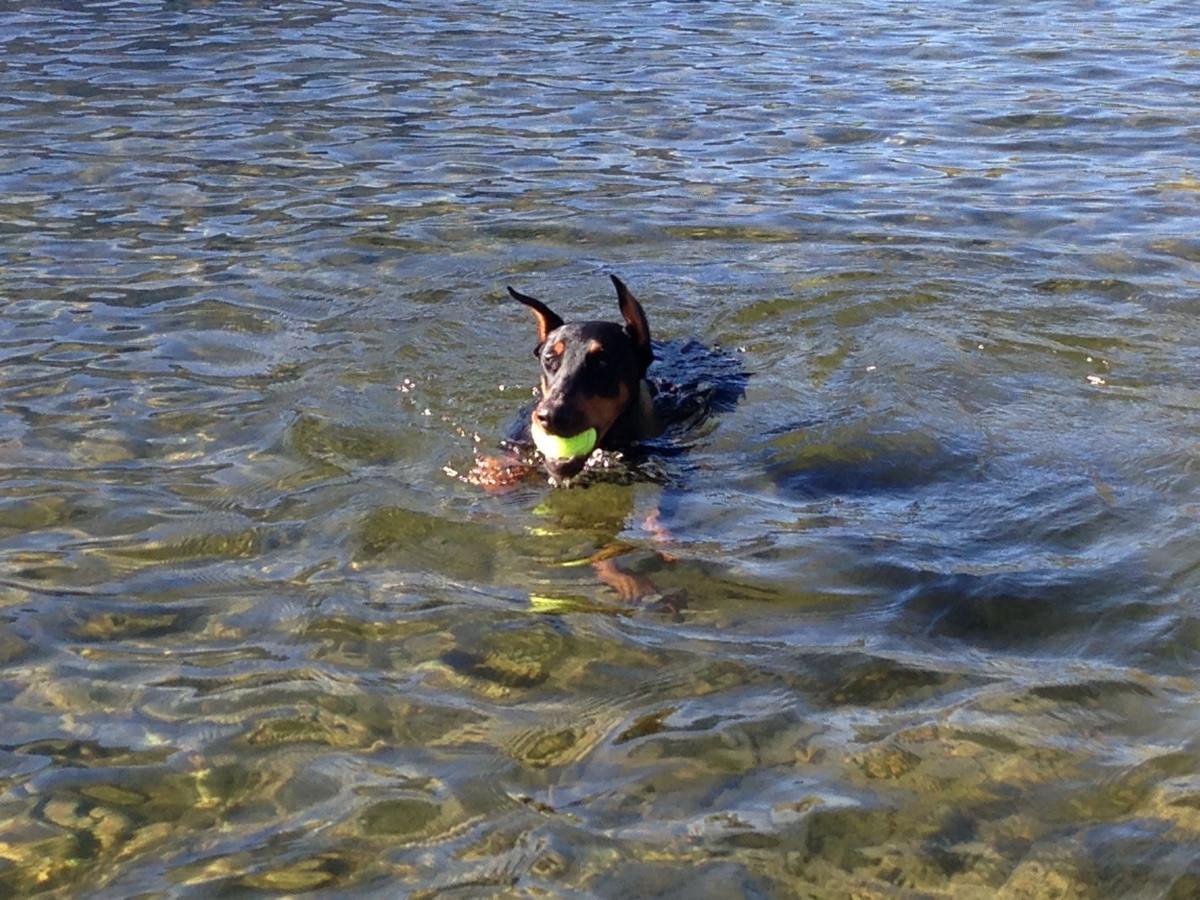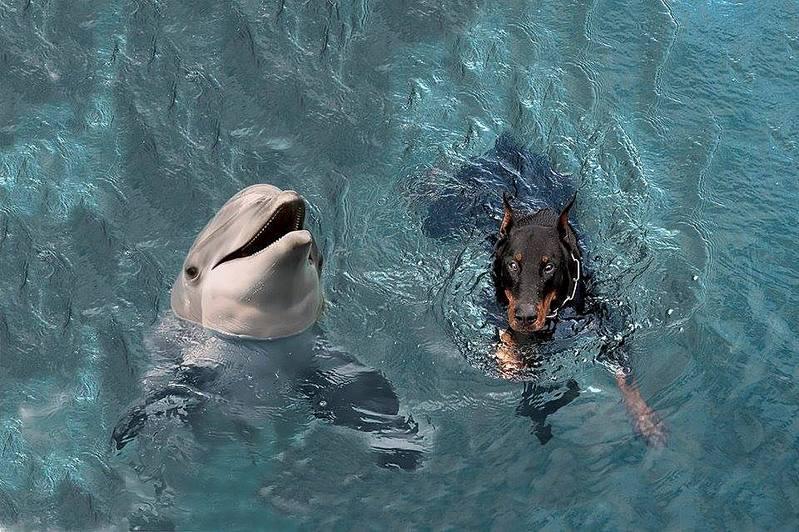The first image is the image on the left, the second image is the image on the right. Evaluate the accuracy of this statement regarding the images: "The dog in each image is alone in the water.". Is it true? Answer yes or no. No. The first image is the image on the left, the second image is the image on the right. Evaluate the accuracy of this statement regarding the images: "There are three animals in the water.". Is it true? Answer yes or no. Yes. 